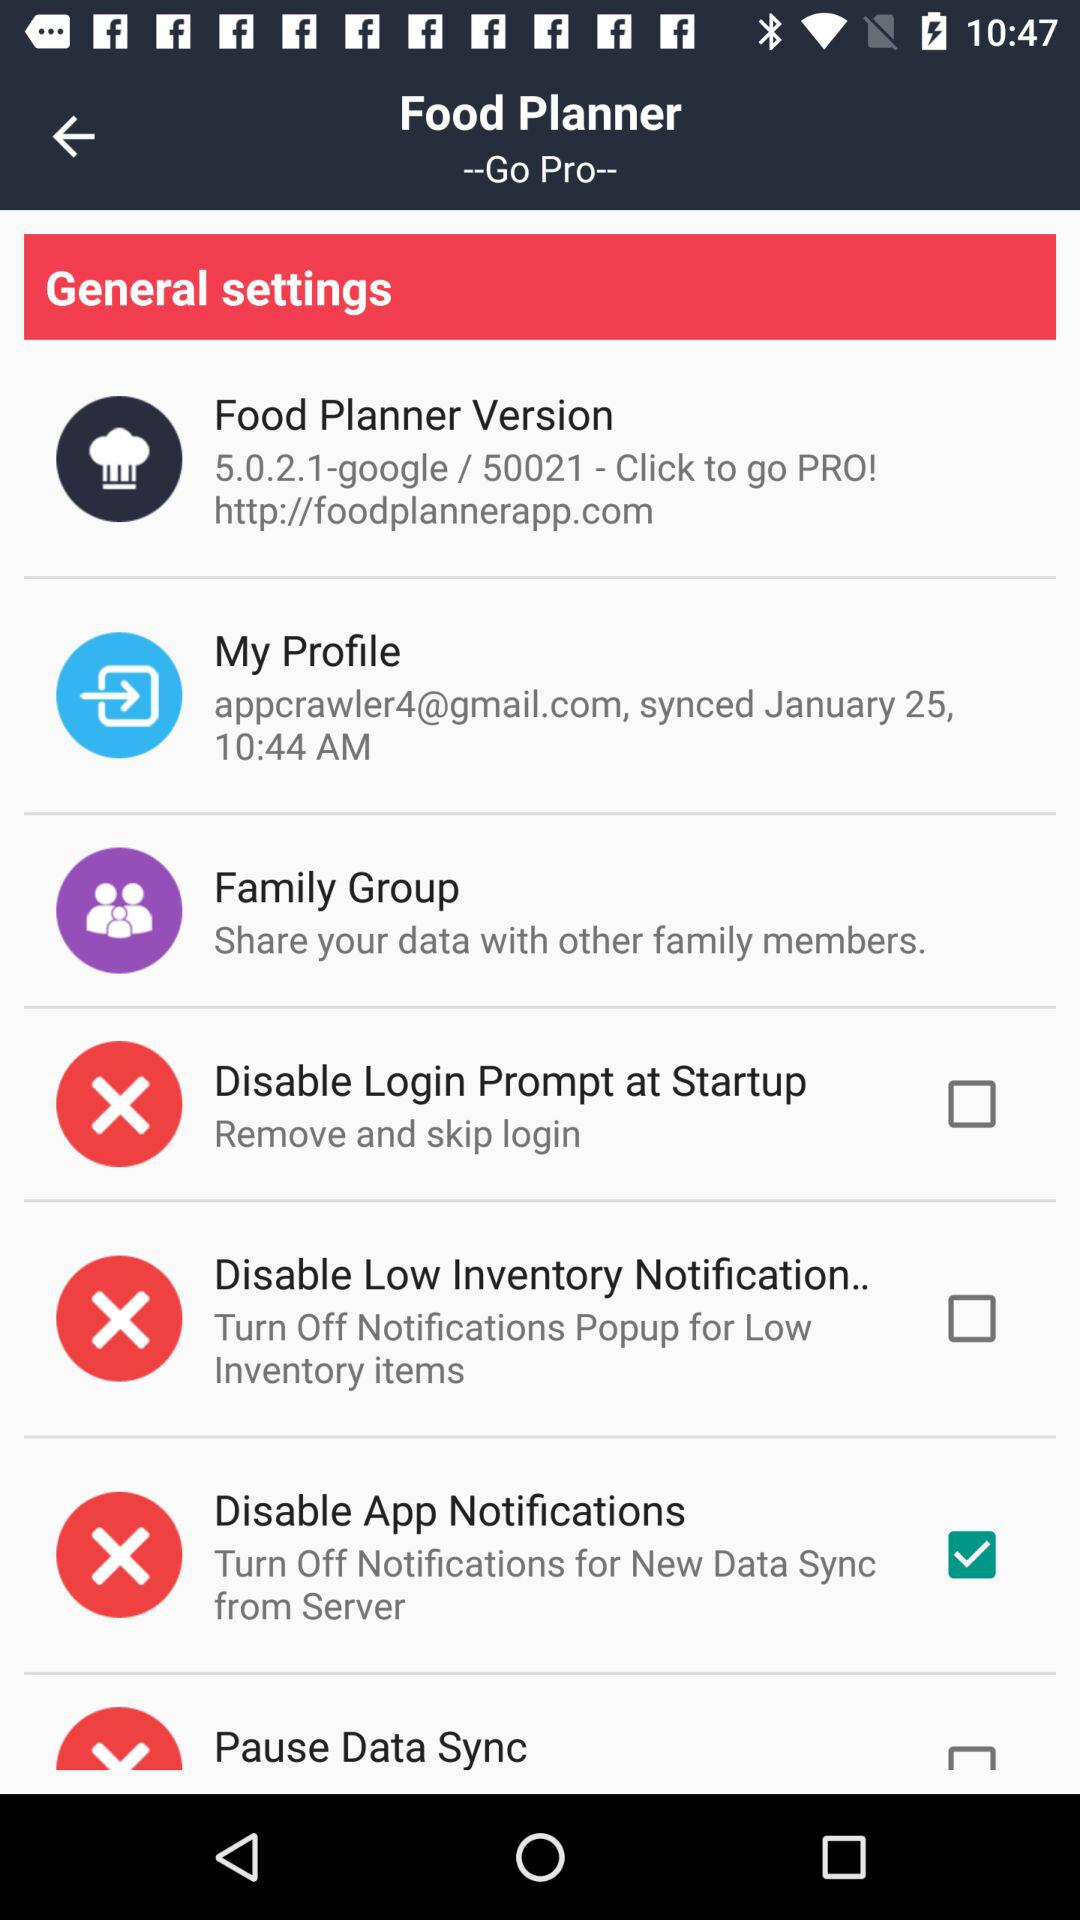Which option is selected? The selected option is "Disable App Notifications". 